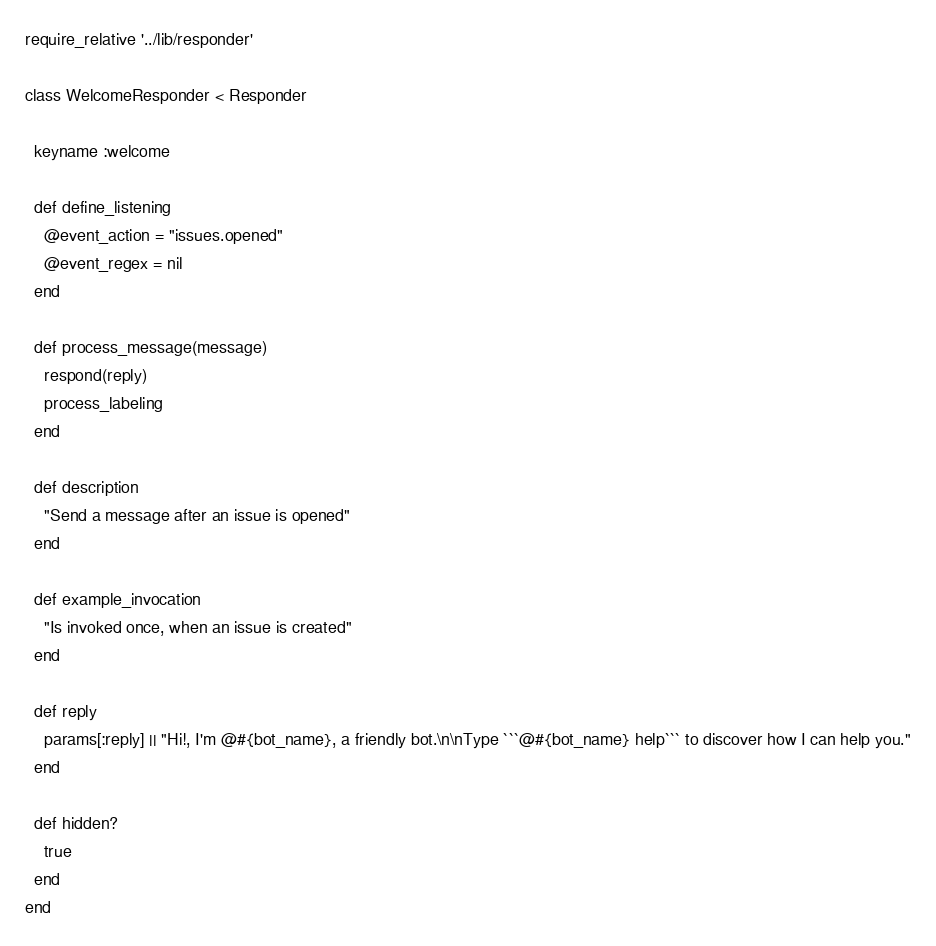<code> <loc_0><loc_0><loc_500><loc_500><_Ruby_>require_relative '../lib/responder'

class WelcomeResponder < Responder

  keyname :welcome

  def define_listening
    @event_action = "issues.opened"
    @event_regex = nil
  end

  def process_message(message)
    respond(reply)
    process_labeling
  end

  def description
    "Send a message after an issue is opened"
  end

  def example_invocation
    "Is invoked once, when an issue is created"
  end

  def reply
    params[:reply] || "Hi!, I'm @#{bot_name}, a friendly bot.\n\nType ```@#{bot_name} help``` to discover how I can help you."
  end

  def hidden?
    true
  end
end
</code> 